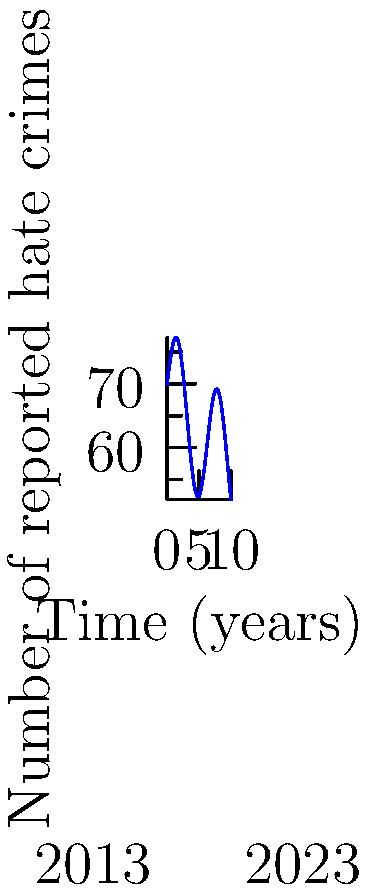The curve above represents the frequency of reported hate crimes over a 10-year period from 2013 to 2023. If this trend continues, calculate the total number of hate crimes expected to be reported over the next 5 years (2023-2028). Express your answer to the nearest whole number. To solve this problem, we need to integrate the given function over the interval [0, 5], as we're looking at the next 5 years.

1) The function appears to be of the form:
   $f(x) = 50 + 10\sin(x) + 20e^{-0.1x}$

2) We need to calculate:
   $$\int_0^5 (50 + 10\sin(x) + 20e^{-0.1x}) dx$$

3) Let's integrate each term separately:
   
   a) $\int_0^5 50 dx = 50x|_0^5 = 250$
   
   b) $\int_0^5 10\sin(x) dx = -10\cos(x)|_0^5 = -10(\cos(5) - 1) \approx 8.775$
   
   c) $\int_0^5 20e^{-0.1x} dx = -200e^{-0.1x}|_0^5 = -200(e^{-0.5} - 1) \approx 90.634$

4) Sum these results:
   $250 + 8.775 + 90.634 = 349.409$

5) Rounding to the nearest whole number:
   349.409 ≈ 349

Therefore, based on this model, approximately 349 hate crimes are expected to be reported over the next 5 years.
Answer: 349 hate crimes 